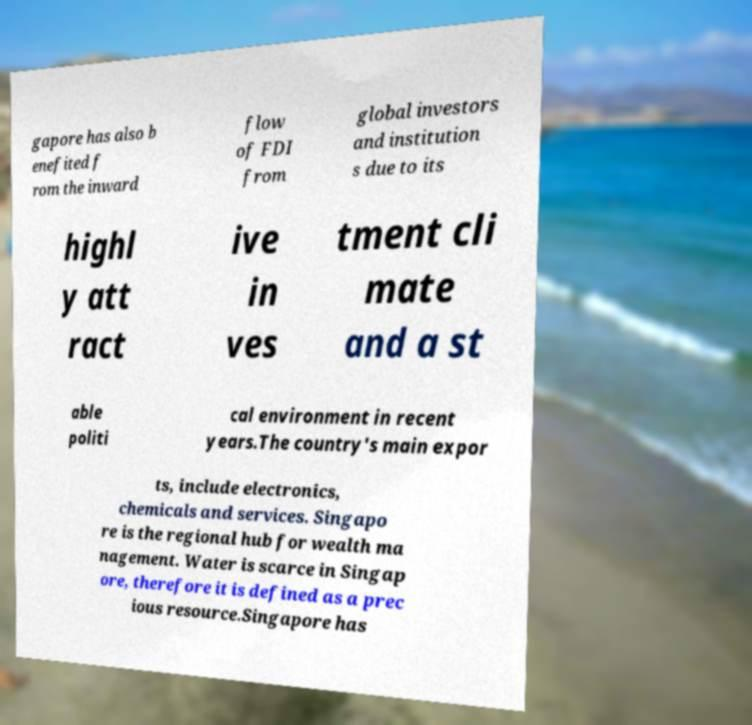Could you assist in decoding the text presented in this image and type it out clearly? gapore has also b enefited f rom the inward flow of FDI from global investors and institution s due to its highl y att ract ive in ves tment cli mate and a st able politi cal environment in recent years.The country's main expor ts, include electronics, chemicals and services. Singapo re is the regional hub for wealth ma nagement. Water is scarce in Singap ore, therefore it is defined as a prec ious resource.Singapore has 